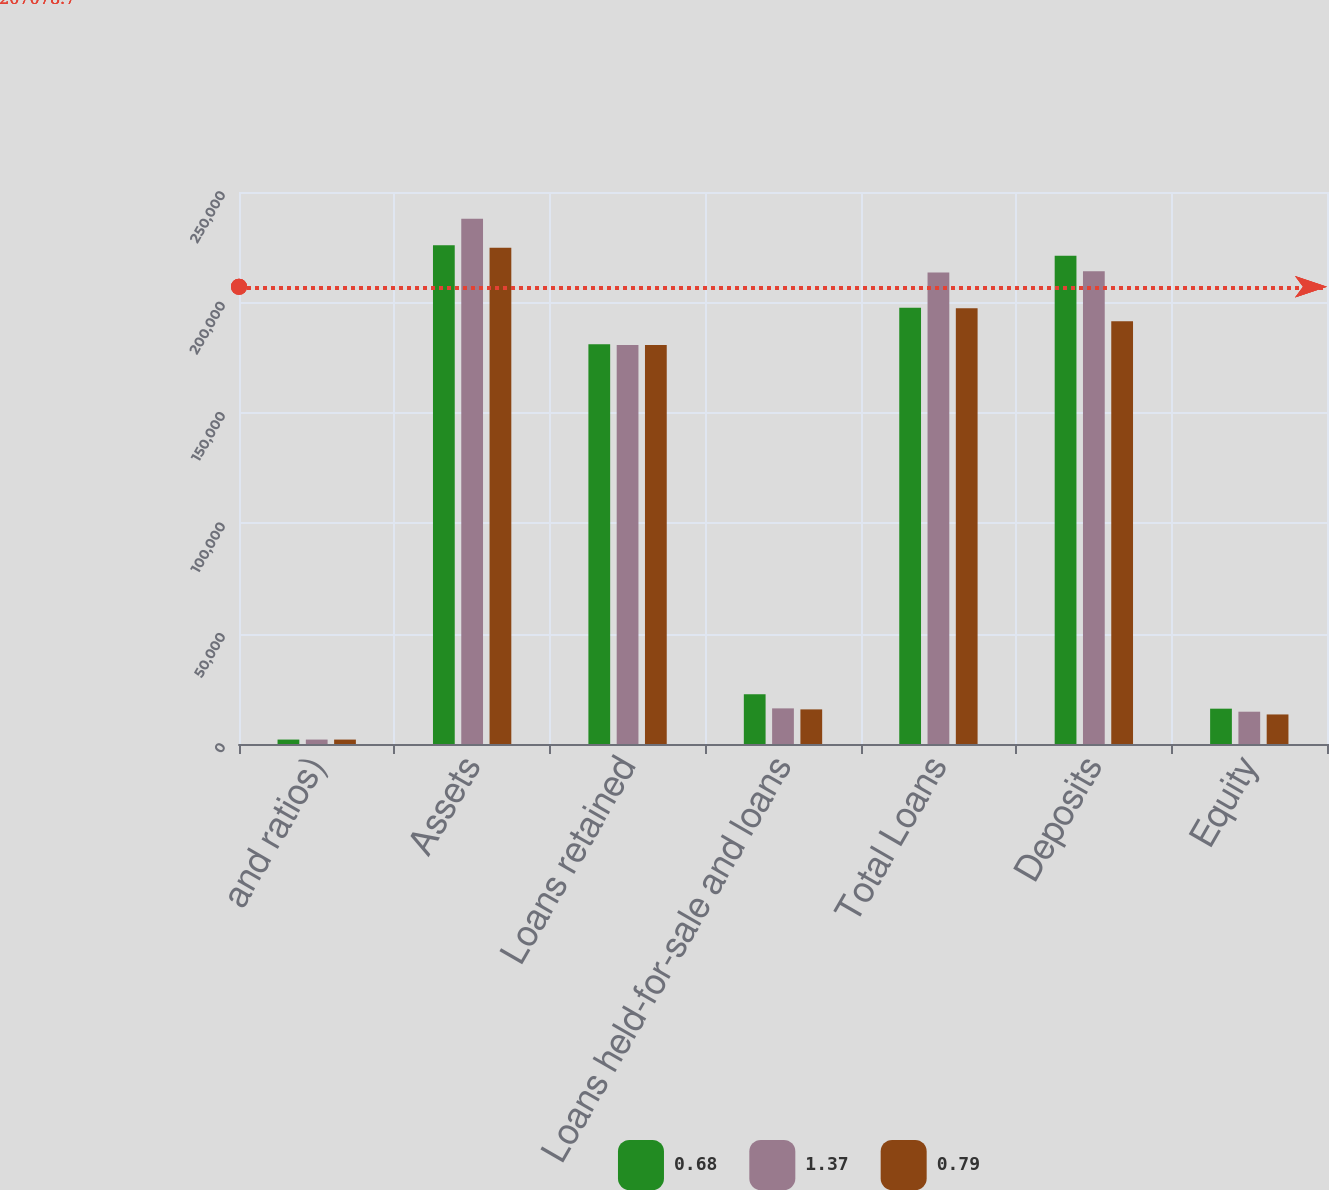<chart> <loc_0><loc_0><loc_500><loc_500><stacked_bar_chart><ecel><fcel>and ratios)<fcel>Assets<fcel>Loans retained<fcel>Loans held-for-sale and loans<fcel>Total Loans<fcel>Deposits<fcel>Equity<nl><fcel>0.68<fcel>2007<fcel>225908<fcel>181016<fcel>22587<fcel>197557<fcel>221129<fcel>16000<nl><fcel>1.37<fcel>2006<fcel>237887<fcel>180760<fcel>16129<fcel>213504<fcel>214081<fcel>14629<nl><fcel>0.79<fcel>2005<fcel>224801<fcel>180701<fcel>15675<fcel>197299<fcel>191415<fcel>13383<nl></chart> 